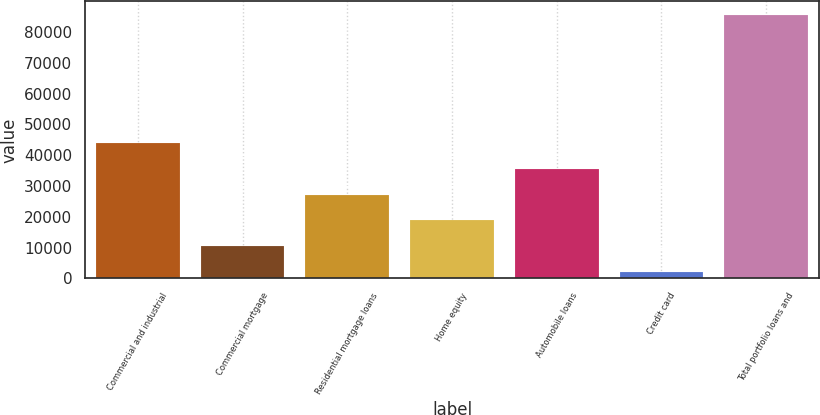Convert chart to OTSL. <chart><loc_0><loc_0><loc_500><loc_500><bar_chart><fcel>Commercial and industrial<fcel>Commercial mortgage<fcel>Residential mortgage loans<fcel>Home equity<fcel>Automobile loans<fcel>Credit card<fcel>Total portfolio loans and<nl><fcel>43901.5<fcel>10457.9<fcel>27179.7<fcel>18818.8<fcel>35540.6<fcel>2097<fcel>85706<nl></chart> 